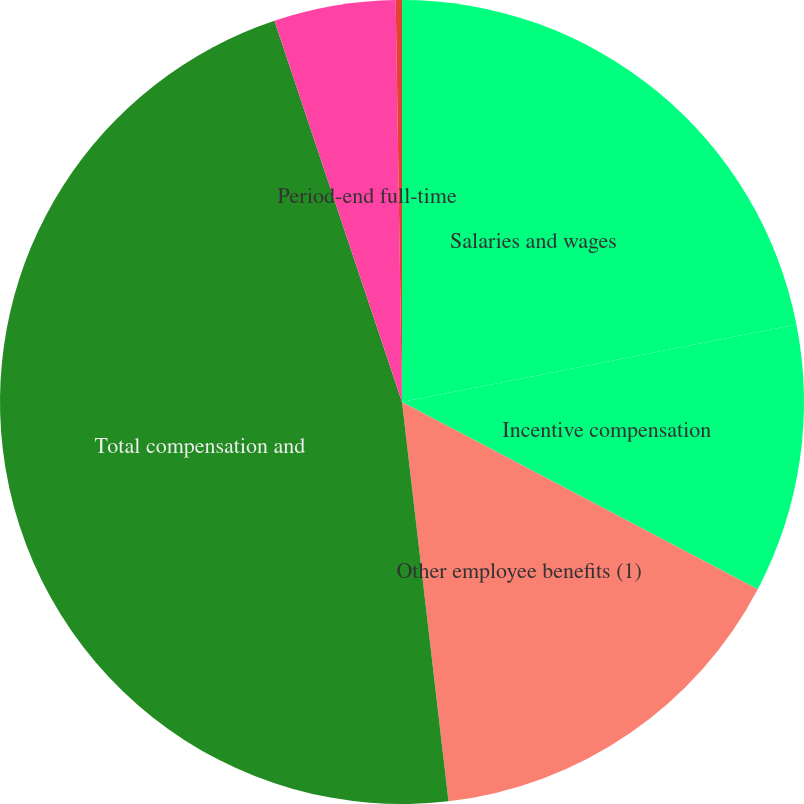Convert chart. <chart><loc_0><loc_0><loc_500><loc_500><pie_chart><fcel>Salaries and wages<fcel>Incentive compensation<fcel>Other employee benefits (1)<fcel>Total compensation and<fcel>Period-end full-time<fcel>Average full-time equivalent<nl><fcel>21.91%<fcel>10.8%<fcel>15.45%<fcel>46.71%<fcel>4.89%<fcel>0.25%<nl></chart> 